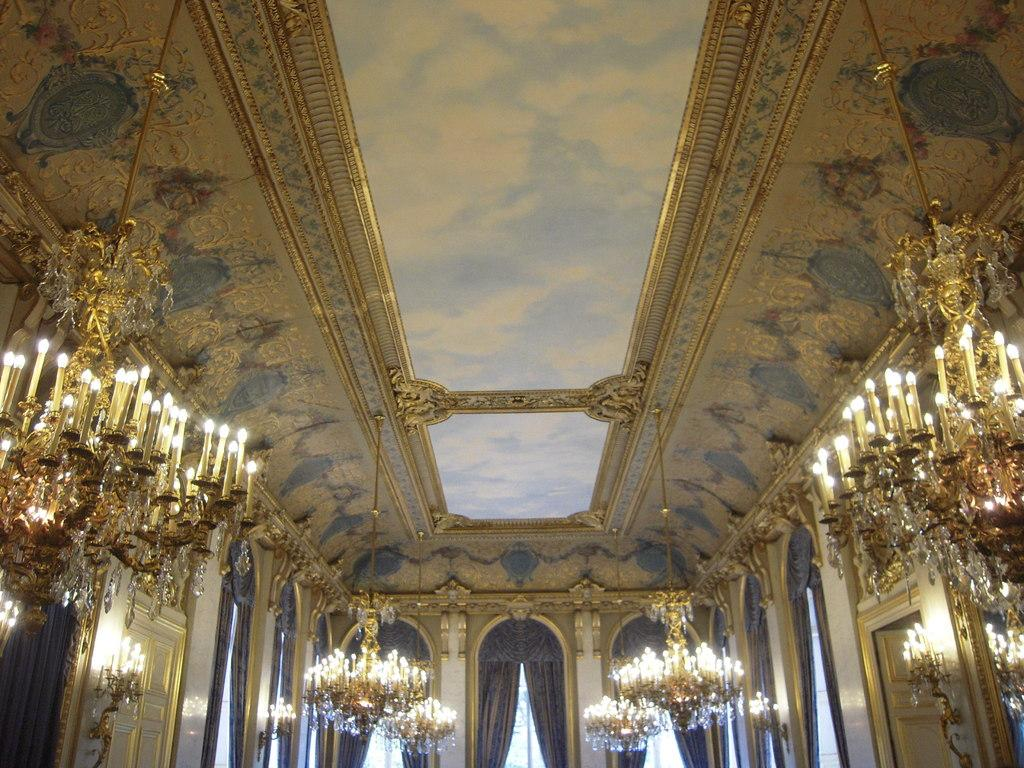Where was the image taken? The image is taken inside a building. What can be seen in the center of the image? There are doors and curtains in the center of the image. What is visible at the top of the image? There is a roof visible at the top of the image. What type of lighting fixture is present in the image? Chandeliers are present in the image. How many cakes are displayed on the table in the image? There are no cakes present in the image. Is there a bottle of wine on the table in the image? There is no bottle of wine visible in the image. 